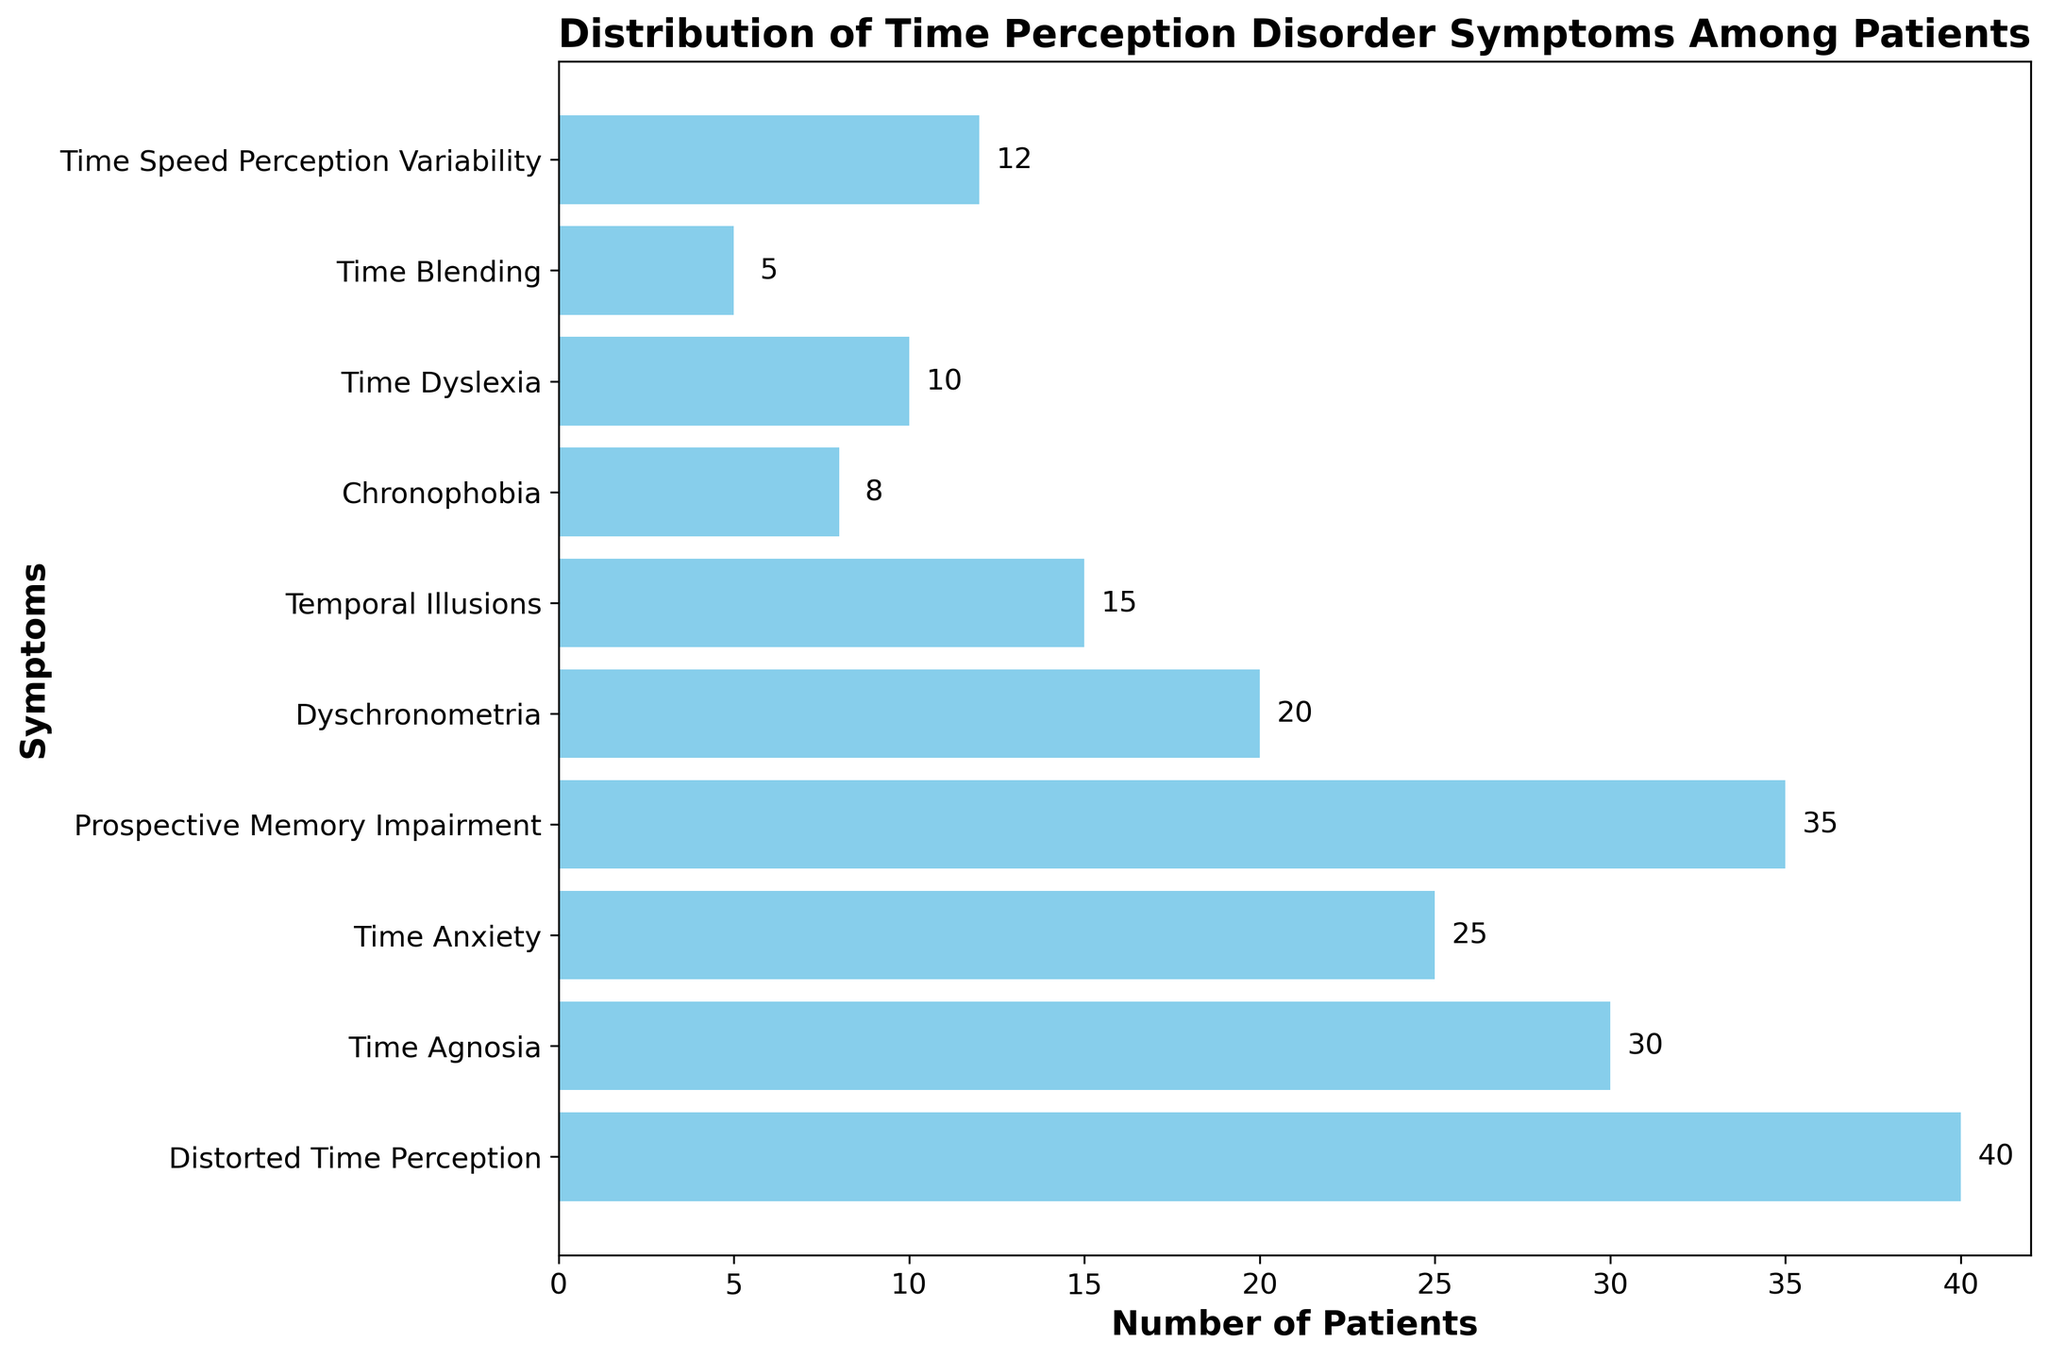What symptom has the highest number of patients? First, observe all the bars and identify the bar that has the greatest horizontal length. The label corresponding to this bar's position on the y-axis will indicate the symptom with the highest count.
Answer: Distorted Time Perception What is the total number of patients reported across all symptoms? Add the numbers associated with each symptom: 40 + 30 + 25 + 35 + 20 + 15 + 8 + 10 + 5 + 12. The resulting sum represents the total patient count.
Answer: 200 How many more patients experience Time Agnosia than Time Blending? Subtract the number of patients with Time Blending (5) from the number of patients with Time Agnosia (30).
Answer: 25 Which symptom has fewer patients, Chronophobia or Time Dyslexia? Compare the horizontal lengths of the bars corresponding to Chronophobia (8 patients) and Time Dyslexia (10 patients). Chronophobia has fewer patients.
Answer: Chronophobia What is the average number of patients per symptom? Sum the number of patients across all symptoms (200) and divide by the total number of symptoms (10). The calculation is 200/10.
Answer: 20 Which symptom has exactly half the number of patients as Prospective Memory Impairment? Identify Prospective Memory Impairment (35 patients). Half of 35 is 17.5, which doesn't match any symptom precisely, so no symptom has exactly half the number of patients.
Answer: None How do the number of patients with Temporal Illusions compare to those with Dyschronometria? Compare the lengths of the bars for Temporal Illusions (15 patients) and Dyschronometria (20 patients). Dyschronometria has more patients.
Answer: Dyschronometria If you sum the number of patients with Time Agnosia and Time Blending, what is the result? Add the number of patients with Time Agnosia (30) and Time Blending (5). The sum is 30 + 5.
Answer: 35 Is the number of patients with Time Anxiety closer to the number for Distorted Time Perception or Time Speed Perception Variability? The number of patients with Time Anxiety (25) is compared to those for Distorted Time Perception (40) and Time Speed Perception Variability (12). The difference between Time Anxiety and Time Speed Perception Variability is 25 - 12 = 13, while the difference with Distorted Time Perception is 40 - 25 = 15. Thus, it is closer to Time Speed Perception Variability.
Answer: Time Speed Perception Variability What percentage of the patients experience Chronophobia? Calculate the percentage by dividing the number of Chronophobia patients (8) by the total number of patients (200) and multiplying by 100. The calculation is (8/200) * 100.
Answer: 4% 